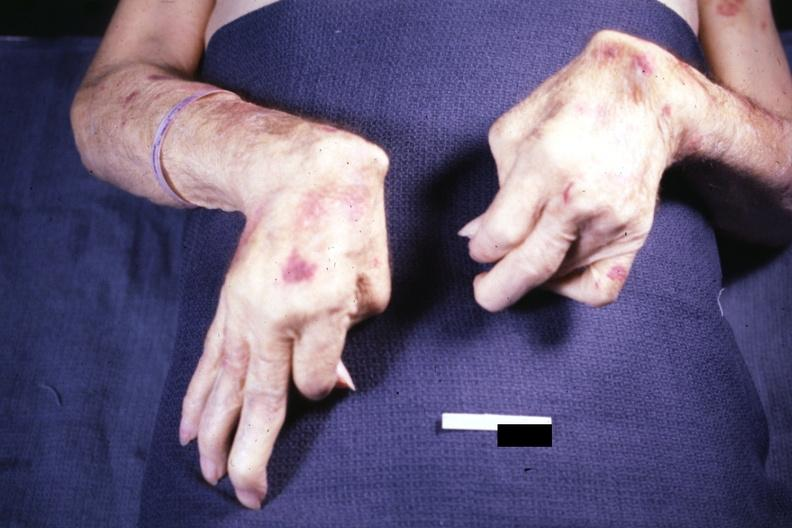s close-up tumor present?
Answer the question using a single word or phrase. No 